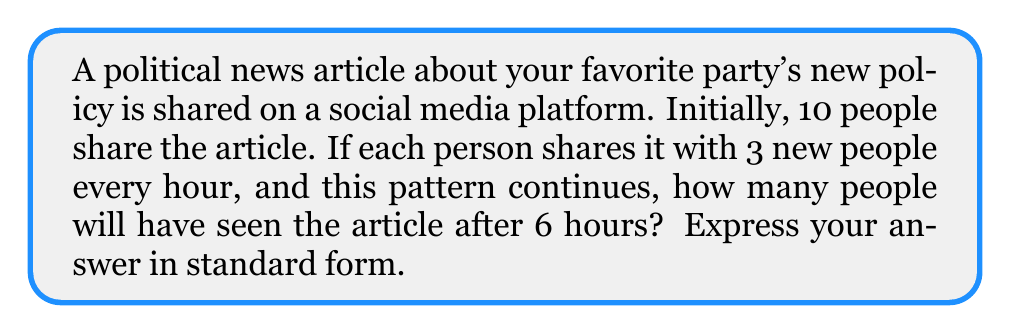Provide a solution to this math problem. Let's approach this step-by-step:

1) We start with 10 people sharing the article.

2) Each hour, the number of people who have seen the article triples.

3) This can be represented as an exponential function:
   $f(t) = 10 \cdot 3^t$, where $t$ is the number of hours.

4) We need to find $f(6)$, as we want to know the number of people after 6 hours.

5) Let's calculate:
   $f(6) = 10 \cdot 3^6$

6) $3^6 = 3 \cdot 3 \cdot 3 \cdot 3 \cdot 3 \cdot 3 = 729$

7) Therefore:
   $f(6) = 10 \cdot 729 = 7,290$

Thus, after 6 hours, 7,290 people will have seen the article.
Answer: 7,290 